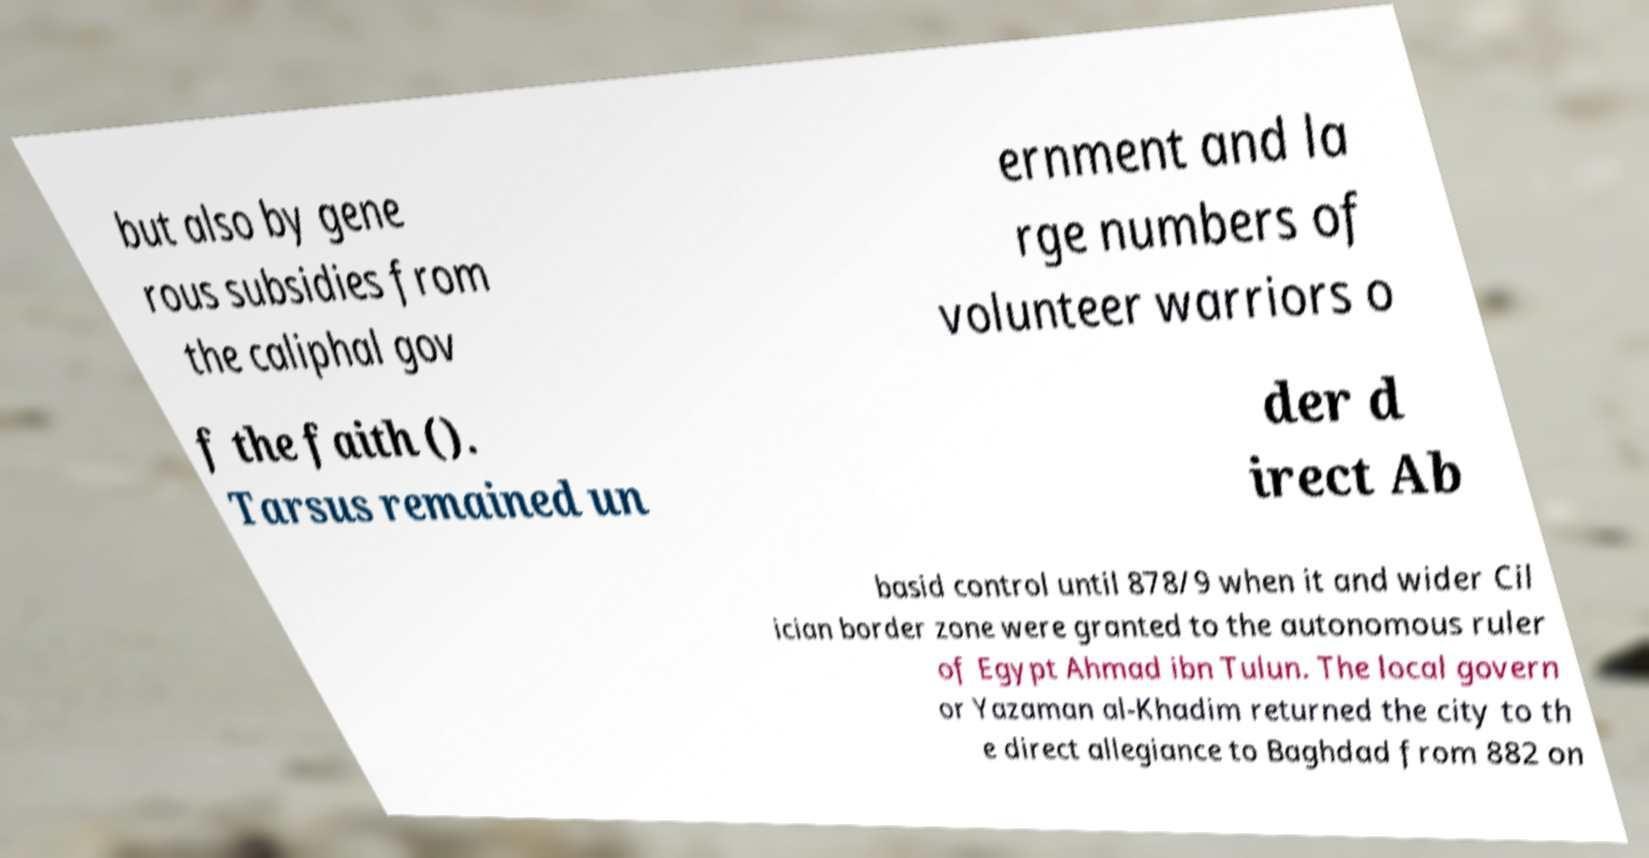What messages or text are displayed in this image? I need them in a readable, typed format. but also by gene rous subsidies from the caliphal gov ernment and la rge numbers of volunteer warriors o f the faith (). Tarsus remained un der d irect Ab basid control until 878/9 when it and wider Cil ician border zone were granted to the autonomous ruler of Egypt Ahmad ibn Tulun. The local govern or Yazaman al-Khadim returned the city to th e direct allegiance to Baghdad from 882 on 